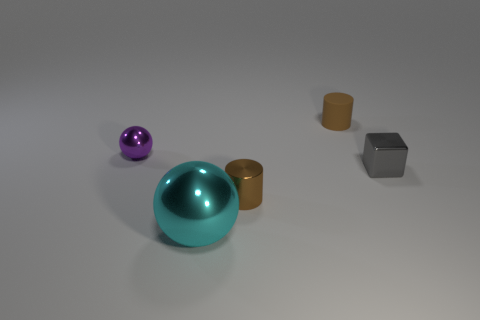There is another small cylinder that is the same color as the shiny cylinder; what is its material?
Your answer should be very brief. Rubber. How many red metal cylinders have the same size as the purple shiny object?
Make the answer very short. 0. Is the color of the sphere that is on the left side of the large metal sphere the same as the metal block?
Provide a succinct answer. No. There is a tiny thing that is both on the right side of the big shiny ball and to the left of the tiny matte thing; what is its material?
Ensure brevity in your answer.  Metal. Is the number of large objects greater than the number of small metallic things?
Offer a very short reply. No. The cylinder in front of the ball that is left of the metallic sphere that is in front of the small sphere is what color?
Provide a succinct answer. Brown. Do the brown thing behind the tiny purple metal object and the large object have the same material?
Keep it short and to the point. No. Are there any other rubber objects of the same color as the large object?
Ensure brevity in your answer.  No. Are any blue shiny spheres visible?
Offer a terse response. No. There is a cylinder that is to the right of the brown shiny thing; is it the same size as the brown shiny object?
Offer a terse response. Yes. 